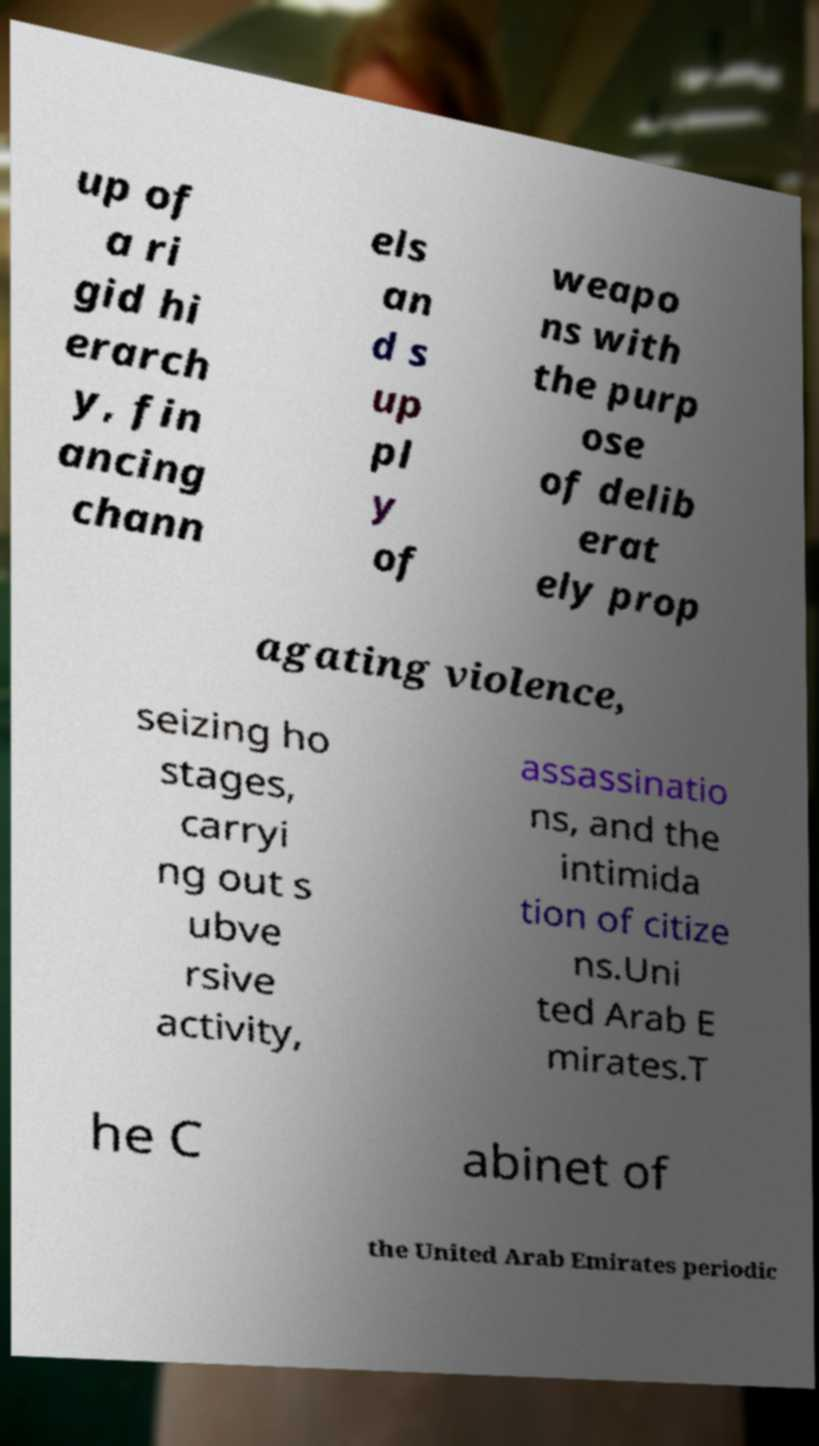I need the written content from this picture converted into text. Can you do that? up of a ri gid hi erarch y, fin ancing chann els an d s up pl y of weapo ns with the purp ose of delib erat ely prop agating violence, seizing ho stages, carryi ng out s ubve rsive activity, assassinatio ns, and the intimida tion of citize ns.Uni ted Arab E mirates.T he C abinet of the United Arab Emirates periodic 